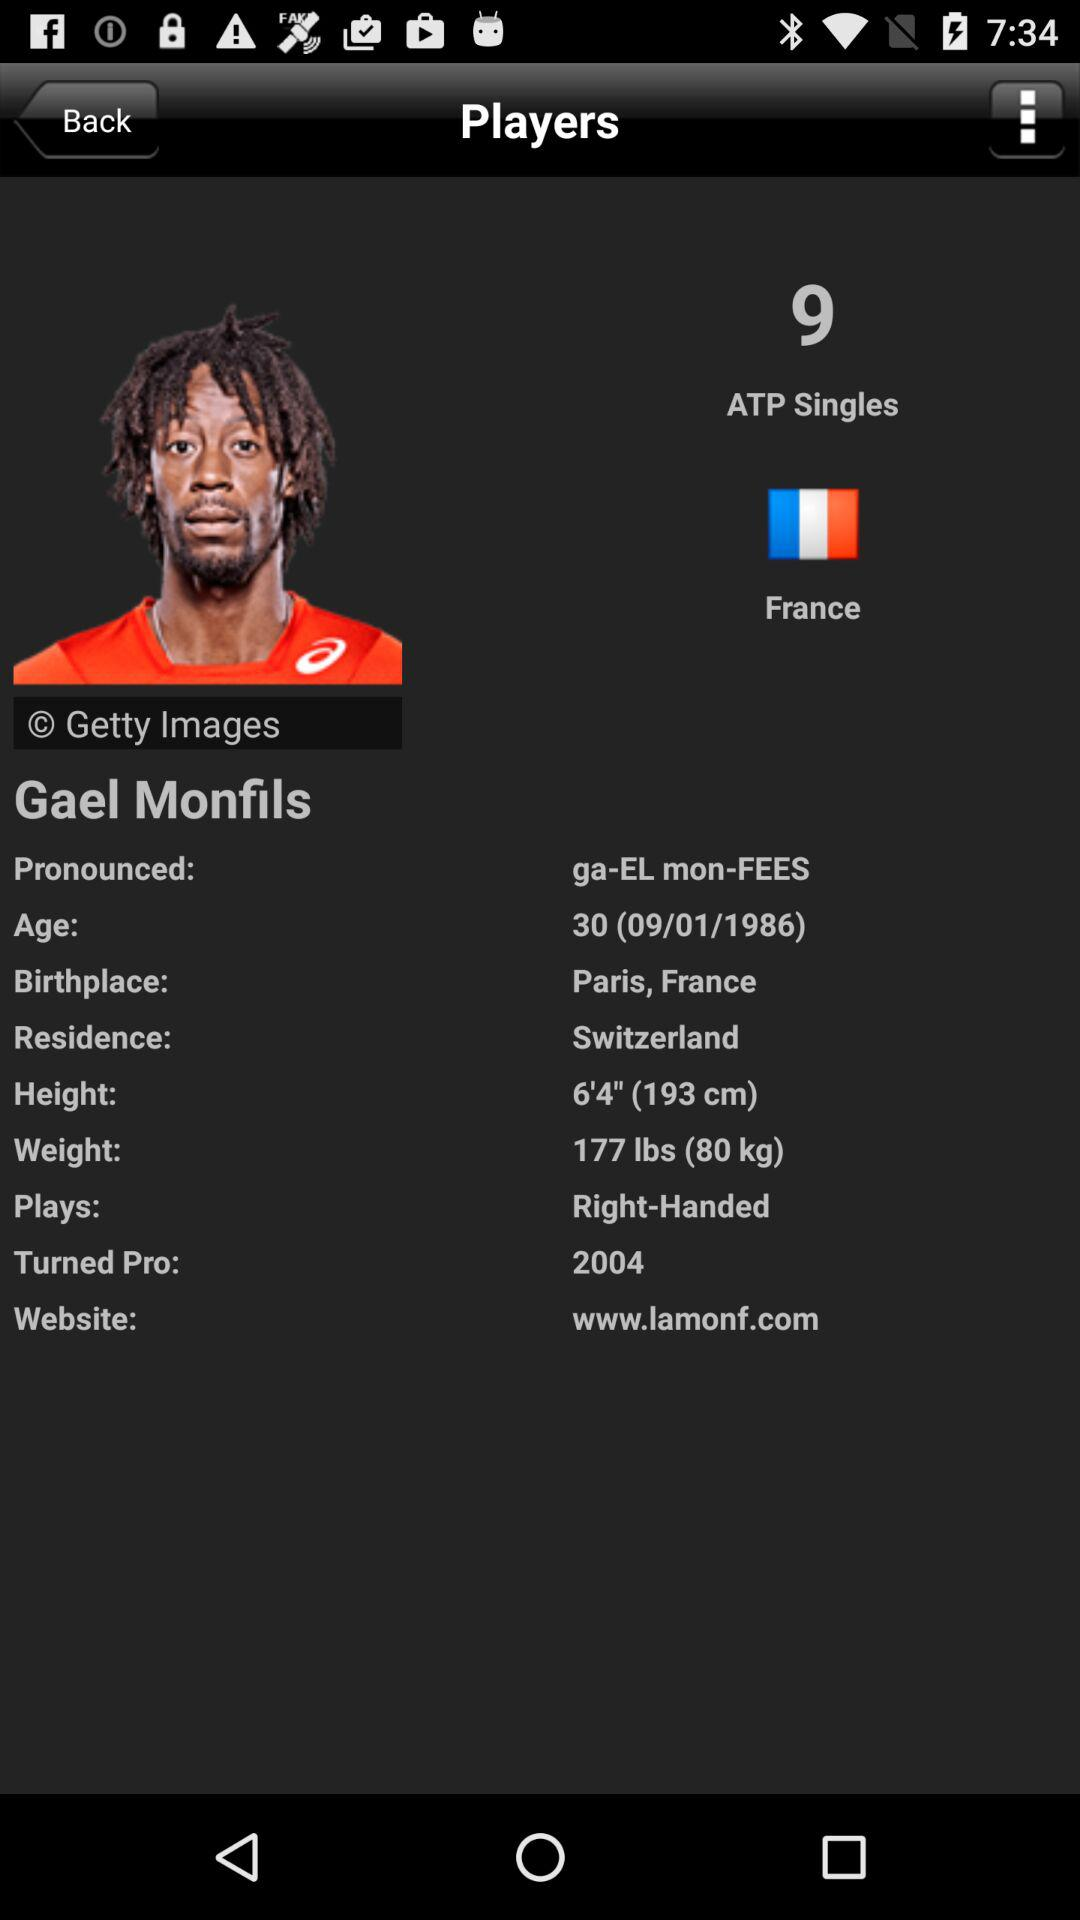What is Gael Monfils's website? Gael Monfils's website is www.lamonf.com. 